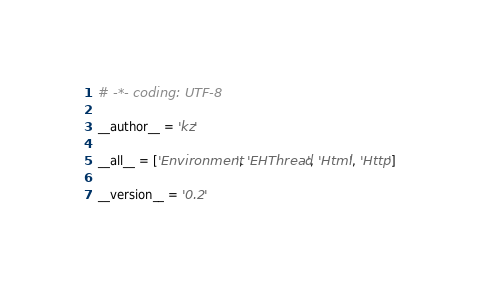<code> <loc_0><loc_0><loc_500><loc_500><_Python_># -*- coding: UTF-8

__author__ = 'kz'

__all__ = ['Environment', 'EHThread', 'Html', 'Http']

__version__ = '0.2'
</code> 